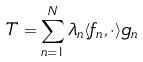<formula> <loc_0><loc_0><loc_500><loc_500>T = \sum _ { n = 1 } ^ { N } \lambda _ { n } \langle f _ { n } , \cdot \rangle g _ { n }</formula> 